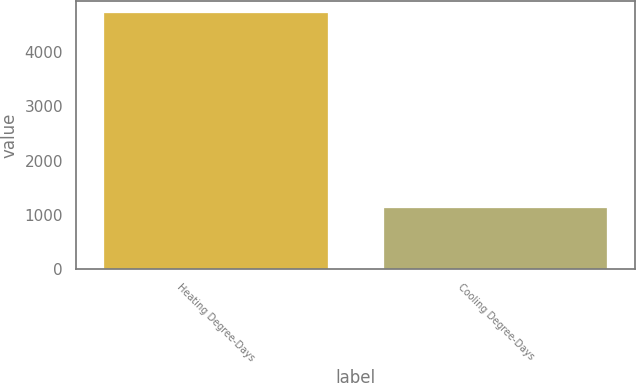<chart> <loc_0><loc_0><loc_500><loc_500><bar_chart><fcel>Heating Degree-Days<fcel>Cooling Degree-Days<nl><fcel>4716<fcel>1122<nl></chart> 